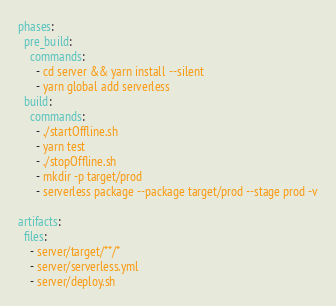<code> <loc_0><loc_0><loc_500><loc_500><_YAML_>phases:
  pre_build:
    commands:
      - cd server && yarn install --silent
      - yarn global add serverless
  build:
    commands:
      - ./startOffline.sh
      - yarn test
      - ./stopOffline.sh
      - mkdir -p target/prod
      - serverless package --package target/prod --stage prod -v

artifacts:
  files:
    - server/target/**/*
    - server/serverless.yml
    - server/deploy.sh</code> 